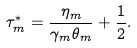Convert formula to latex. <formula><loc_0><loc_0><loc_500><loc_500>\tau _ { m } ^ { * } = \frac { \eta _ { m } } { \gamma _ { m } \theta _ { m } } + \frac { 1 } { 2 } .</formula> 